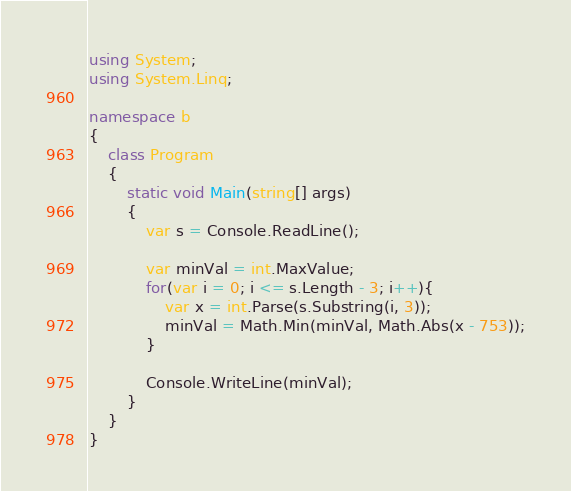Convert code to text. <code><loc_0><loc_0><loc_500><loc_500><_C#_>using System;
using System.Linq;

namespace b
{
    class Program
    {
        static void Main(string[] args)
        {
            var s = Console.ReadLine();

            var minVal = int.MaxValue;
            for(var i = 0; i <= s.Length - 3; i++){
                var x = int.Parse(s.Substring(i, 3));
                minVal = Math.Min(minVal, Math.Abs(x - 753));
            }

            Console.WriteLine(minVal);
        }
    }
}
</code> 